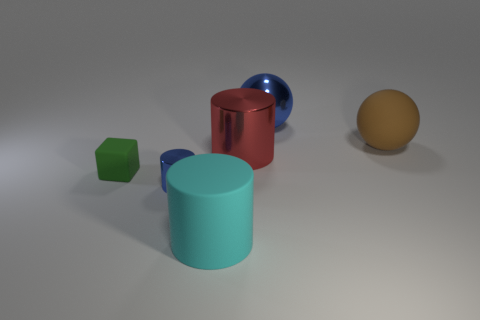There is a cyan thing that is left of the blue object that is behind the tiny thing in front of the small green rubber cube; how big is it?
Provide a short and direct response. Large. There is a red metal thing; is its shape the same as the blue metallic object behind the brown matte thing?
Provide a succinct answer. No. What material is the small green object?
Provide a short and direct response. Rubber. How many rubber things are either blue blocks or small cubes?
Give a very brief answer. 1. Are there fewer brown rubber things that are in front of the green matte object than shiny things behind the blue metal cylinder?
Offer a terse response. Yes. Is there a matte ball that is in front of the large cylinder on the right side of the big rubber thing left of the big shiny sphere?
Provide a succinct answer. No. What is the material of the big ball that is the same color as the tiny cylinder?
Provide a succinct answer. Metal. Does the rubber object to the right of the big shiny cylinder have the same shape as the large cyan rubber object that is left of the blue ball?
Provide a succinct answer. No. What material is the brown object that is the same size as the metallic sphere?
Provide a succinct answer. Rubber. Is the ball to the left of the brown matte sphere made of the same material as the blue object that is in front of the big brown ball?
Keep it short and to the point. Yes. 